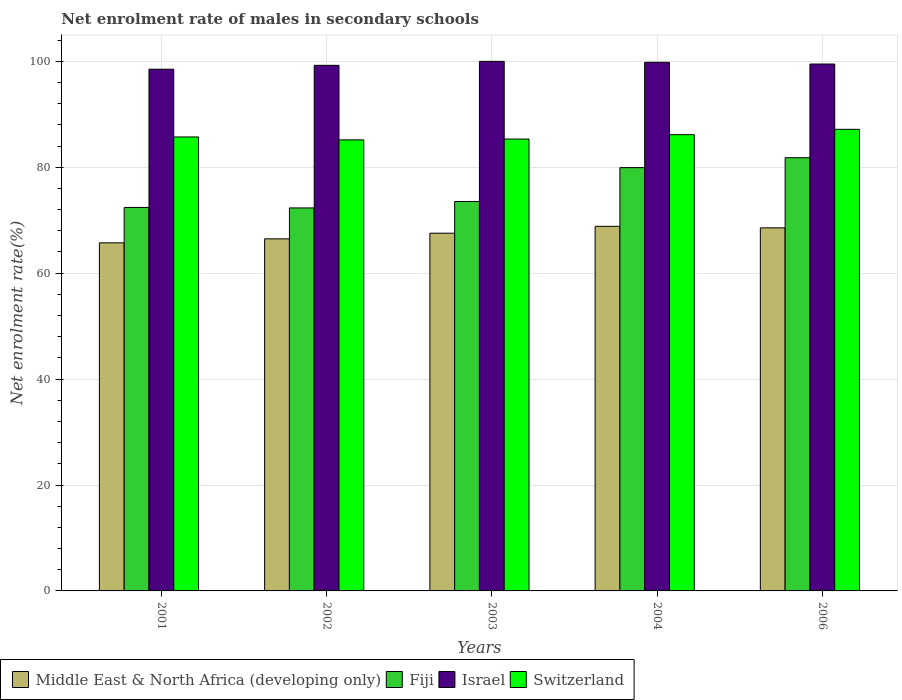How many groups of bars are there?
Make the answer very short. 5. Are the number of bars per tick equal to the number of legend labels?
Offer a very short reply. Yes. How many bars are there on the 2nd tick from the left?
Your response must be concise. 4. How many bars are there on the 5th tick from the right?
Your answer should be very brief. 4. What is the label of the 1st group of bars from the left?
Provide a succinct answer. 2001. What is the net enrolment rate of males in secondary schools in Middle East & North Africa (developing only) in 2001?
Offer a very short reply. 65.73. Across all years, what is the maximum net enrolment rate of males in secondary schools in Switzerland?
Provide a succinct answer. 87.17. Across all years, what is the minimum net enrolment rate of males in secondary schools in Fiji?
Your response must be concise. 72.32. In which year was the net enrolment rate of males in secondary schools in Middle East & North Africa (developing only) maximum?
Your answer should be very brief. 2004. In which year was the net enrolment rate of males in secondary schools in Israel minimum?
Provide a short and direct response. 2001. What is the total net enrolment rate of males in secondary schools in Middle East & North Africa (developing only) in the graph?
Ensure brevity in your answer.  337.18. What is the difference between the net enrolment rate of males in secondary schools in Israel in 2001 and that in 2004?
Your answer should be compact. -1.31. What is the difference between the net enrolment rate of males in secondary schools in Fiji in 2003 and the net enrolment rate of males in secondary schools in Switzerland in 2001?
Your answer should be very brief. -12.19. What is the average net enrolment rate of males in secondary schools in Fiji per year?
Provide a succinct answer. 76. In the year 2002, what is the difference between the net enrolment rate of males in secondary schools in Switzerland and net enrolment rate of males in secondary schools in Middle East & North Africa (developing only)?
Your response must be concise. 18.69. What is the ratio of the net enrolment rate of males in secondary schools in Fiji in 2001 to that in 2004?
Provide a short and direct response. 0.91. What is the difference between the highest and the second highest net enrolment rate of males in secondary schools in Switzerland?
Provide a succinct answer. 1.01. What is the difference between the highest and the lowest net enrolment rate of males in secondary schools in Middle East & North Africa (developing only)?
Your answer should be compact. 3.12. What does the 3rd bar from the left in 2001 represents?
Your answer should be compact. Israel. What does the 1st bar from the right in 2001 represents?
Provide a succinct answer. Switzerland. How many bars are there?
Your answer should be very brief. 20. Does the graph contain grids?
Give a very brief answer. Yes. Where does the legend appear in the graph?
Your answer should be very brief. Bottom left. How many legend labels are there?
Your answer should be compact. 4. What is the title of the graph?
Keep it short and to the point. Net enrolment rate of males in secondary schools. What is the label or title of the X-axis?
Your answer should be very brief. Years. What is the label or title of the Y-axis?
Your response must be concise. Net enrolment rate(%). What is the Net enrolment rate(%) in Middle East & North Africa (developing only) in 2001?
Make the answer very short. 65.73. What is the Net enrolment rate(%) of Fiji in 2001?
Provide a succinct answer. 72.42. What is the Net enrolment rate(%) of Israel in 2001?
Offer a very short reply. 98.52. What is the Net enrolment rate(%) of Switzerland in 2001?
Your answer should be compact. 85.72. What is the Net enrolment rate(%) of Middle East & North Africa (developing only) in 2002?
Provide a succinct answer. 66.48. What is the Net enrolment rate(%) in Fiji in 2002?
Your answer should be very brief. 72.32. What is the Net enrolment rate(%) of Israel in 2002?
Provide a succinct answer. 99.25. What is the Net enrolment rate(%) of Switzerland in 2002?
Your answer should be very brief. 85.17. What is the Net enrolment rate(%) in Middle East & North Africa (developing only) in 2003?
Offer a terse response. 67.55. What is the Net enrolment rate(%) in Fiji in 2003?
Provide a succinct answer. 73.54. What is the Net enrolment rate(%) in Switzerland in 2003?
Provide a succinct answer. 85.33. What is the Net enrolment rate(%) of Middle East & North Africa (developing only) in 2004?
Ensure brevity in your answer.  68.85. What is the Net enrolment rate(%) in Fiji in 2004?
Give a very brief answer. 79.93. What is the Net enrolment rate(%) in Israel in 2004?
Make the answer very short. 99.82. What is the Net enrolment rate(%) of Switzerland in 2004?
Offer a very short reply. 86.16. What is the Net enrolment rate(%) in Middle East & North Africa (developing only) in 2006?
Make the answer very short. 68.56. What is the Net enrolment rate(%) of Fiji in 2006?
Provide a succinct answer. 81.81. What is the Net enrolment rate(%) in Israel in 2006?
Provide a short and direct response. 99.5. What is the Net enrolment rate(%) of Switzerland in 2006?
Your answer should be very brief. 87.17. Across all years, what is the maximum Net enrolment rate(%) in Middle East & North Africa (developing only)?
Your answer should be compact. 68.85. Across all years, what is the maximum Net enrolment rate(%) in Fiji?
Ensure brevity in your answer.  81.81. Across all years, what is the maximum Net enrolment rate(%) in Switzerland?
Provide a succinct answer. 87.17. Across all years, what is the minimum Net enrolment rate(%) in Middle East & North Africa (developing only)?
Give a very brief answer. 65.73. Across all years, what is the minimum Net enrolment rate(%) of Fiji?
Your answer should be very brief. 72.32. Across all years, what is the minimum Net enrolment rate(%) of Israel?
Provide a succinct answer. 98.52. Across all years, what is the minimum Net enrolment rate(%) of Switzerland?
Your answer should be compact. 85.17. What is the total Net enrolment rate(%) in Middle East & North Africa (developing only) in the graph?
Provide a succinct answer. 337.18. What is the total Net enrolment rate(%) in Fiji in the graph?
Your answer should be very brief. 380.01. What is the total Net enrolment rate(%) of Israel in the graph?
Your answer should be compact. 497.08. What is the total Net enrolment rate(%) of Switzerland in the graph?
Your answer should be compact. 429.55. What is the difference between the Net enrolment rate(%) in Middle East & North Africa (developing only) in 2001 and that in 2002?
Your answer should be very brief. -0.75. What is the difference between the Net enrolment rate(%) in Fiji in 2001 and that in 2002?
Your answer should be very brief. 0.09. What is the difference between the Net enrolment rate(%) in Israel in 2001 and that in 2002?
Make the answer very short. -0.73. What is the difference between the Net enrolment rate(%) in Switzerland in 2001 and that in 2002?
Your answer should be compact. 0.55. What is the difference between the Net enrolment rate(%) in Middle East & North Africa (developing only) in 2001 and that in 2003?
Provide a short and direct response. -1.82. What is the difference between the Net enrolment rate(%) of Fiji in 2001 and that in 2003?
Keep it short and to the point. -1.12. What is the difference between the Net enrolment rate(%) of Israel in 2001 and that in 2003?
Ensure brevity in your answer.  -1.48. What is the difference between the Net enrolment rate(%) of Switzerland in 2001 and that in 2003?
Provide a short and direct response. 0.4. What is the difference between the Net enrolment rate(%) of Middle East & North Africa (developing only) in 2001 and that in 2004?
Offer a terse response. -3.12. What is the difference between the Net enrolment rate(%) in Fiji in 2001 and that in 2004?
Ensure brevity in your answer.  -7.52. What is the difference between the Net enrolment rate(%) in Israel in 2001 and that in 2004?
Your answer should be very brief. -1.31. What is the difference between the Net enrolment rate(%) of Switzerland in 2001 and that in 2004?
Ensure brevity in your answer.  -0.43. What is the difference between the Net enrolment rate(%) in Middle East & North Africa (developing only) in 2001 and that in 2006?
Your response must be concise. -2.83. What is the difference between the Net enrolment rate(%) of Fiji in 2001 and that in 2006?
Your response must be concise. -9.39. What is the difference between the Net enrolment rate(%) of Israel in 2001 and that in 2006?
Your response must be concise. -0.98. What is the difference between the Net enrolment rate(%) of Switzerland in 2001 and that in 2006?
Your answer should be compact. -1.44. What is the difference between the Net enrolment rate(%) of Middle East & North Africa (developing only) in 2002 and that in 2003?
Keep it short and to the point. -1.07. What is the difference between the Net enrolment rate(%) in Fiji in 2002 and that in 2003?
Give a very brief answer. -1.21. What is the difference between the Net enrolment rate(%) in Israel in 2002 and that in 2003?
Your answer should be very brief. -0.75. What is the difference between the Net enrolment rate(%) in Switzerland in 2002 and that in 2003?
Give a very brief answer. -0.16. What is the difference between the Net enrolment rate(%) in Middle East & North Africa (developing only) in 2002 and that in 2004?
Your answer should be compact. -2.36. What is the difference between the Net enrolment rate(%) in Fiji in 2002 and that in 2004?
Provide a succinct answer. -7.61. What is the difference between the Net enrolment rate(%) of Israel in 2002 and that in 2004?
Make the answer very short. -0.58. What is the difference between the Net enrolment rate(%) in Switzerland in 2002 and that in 2004?
Your answer should be compact. -0.98. What is the difference between the Net enrolment rate(%) in Middle East & North Africa (developing only) in 2002 and that in 2006?
Your response must be concise. -2.08. What is the difference between the Net enrolment rate(%) of Fiji in 2002 and that in 2006?
Your answer should be compact. -9.49. What is the difference between the Net enrolment rate(%) of Israel in 2002 and that in 2006?
Offer a very short reply. -0.25. What is the difference between the Net enrolment rate(%) of Switzerland in 2002 and that in 2006?
Offer a very short reply. -1.99. What is the difference between the Net enrolment rate(%) of Middle East & North Africa (developing only) in 2003 and that in 2004?
Offer a very short reply. -1.3. What is the difference between the Net enrolment rate(%) of Fiji in 2003 and that in 2004?
Ensure brevity in your answer.  -6.4. What is the difference between the Net enrolment rate(%) of Israel in 2003 and that in 2004?
Your answer should be very brief. 0.18. What is the difference between the Net enrolment rate(%) of Switzerland in 2003 and that in 2004?
Give a very brief answer. -0.83. What is the difference between the Net enrolment rate(%) of Middle East & North Africa (developing only) in 2003 and that in 2006?
Your answer should be compact. -1.01. What is the difference between the Net enrolment rate(%) of Fiji in 2003 and that in 2006?
Your response must be concise. -8.27. What is the difference between the Net enrolment rate(%) in Israel in 2003 and that in 2006?
Your response must be concise. 0.5. What is the difference between the Net enrolment rate(%) of Switzerland in 2003 and that in 2006?
Your answer should be compact. -1.84. What is the difference between the Net enrolment rate(%) of Middle East & North Africa (developing only) in 2004 and that in 2006?
Keep it short and to the point. 0.29. What is the difference between the Net enrolment rate(%) in Fiji in 2004 and that in 2006?
Provide a short and direct response. -1.87. What is the difference between the Net enrolment rate(%) in Israel in 2004 and that in 2006?
Give a very brief answer. 0.33. What is the difference between the Net enrolment rate(%) of Switzerland in 2004 and that in 2006?
Give a very brief answer. -1.01. What is the difference between the Net enrolment rate(%) of Middle East & North Africa (developing only) in 2001 and the Net enrolment rate(%) of Fiji in 2002?
Your answer should be very brief. -6.59. What is the difference between the Net enrolment rate(%) of Middle East & North Africa (developing only) in 2001 and the Net enrolment rate(%) of Israel in 2002?
Ensure brevity in your answer.  -33.51. What is the difference between the Net enrolment rate(%) in Middle East & North Africa (developing only) in 2001 and the Net enrolment rate(%) in Switzerland in 2002?
Provide a short and direct response. -19.44. What is the difference between the Net enrolment rate(%) of Fiji in 2001 and the Net enrolment rate(%) of Israel in 2002?
Give a very brief answer. -26.83. What is the difference between the Net enrolment rate(%) in Fiji in 2001 and the Net enrolment rate(%) in Switzerland in 2002?
Provide a succinct answer. -12.76. What is the difference between the Net enrolment rate(%) of Israel in 2001 and the Net enrolment rate(%) of Switzerland in 2002?
Ensure brevity in your answer.  13.34. What is the difference between the Net enrolment rate(%) of Middle East & North Africa (developing only) in 2001 and the Net enrolment rate(%) of Fiji in 2003?
Provide a succinct answer. -7.8. What is the difference between the Net enrolment rate(%) in Middle East & North Africa (developing only) in 2001 and the Net enrolment rate(%) in Israel in 2003?
Your answer should be compact. -34.27. What is the difference between the Net enrolment rate(%) in Middle East & North Africa (developing only) in 2001 and the Net enrolment rate(%) in Switzerland in 2003?
Provide a succinct answer. -19.6. What is the difference between the Net enrolment rate(%) of Fiji in 2001 and the Net enrolment rate(%) of Israel in 2003?
Give a very brief answer. -27.58. What is the difference between the Net enrolment rate(%) in Fiji in 2001 and the Net enrolment rate(%) in Switzerland in 2003?
Your answer should be very brief. -12.91. What is the difference between the Net enrolment rate(%) in Israel in 2001 and the Net enrolment rate(%) in Switzerland in 2003?
Offer a very short reply. 13.19. What is the difference between the Net enrolment rate(%) in Middle East & North Africa (developing only) in 2001 and the Net enrolment rate(%) in Fiji in 2004?
Offer a terse response. -14.2. What is the difference between the Net enrolment rate(%) in Middle East & North Africa (developing only) in 2001 and the Net enrolment rate(%) in Israel in 2004?
Ensure brevity in your answer.  -34.09. What is the difference between the Net enrolment rate(%) in Middle East & North Africa (developing only) in 2001 and the Net enrolment rate(%) in Switzerland in 2004?
Keep it short and to the point. -20.42. What is the difference between the Net enrolment rate(%) in Fiji in 2001 and the Net enrolment rate(%) in Israel in 2004?
Give a very brief answer. -27.41. What is the difference between the Net enrolment rate(%) in Fiji in 2001 and the Net enrolment rate(%) in Switzerland in 2004?
Make the answer very short. -13.74. What is the difference between the Net enrolment rate(%) in Israel in 2001 and the Net enrolment rate(%) in Switzerland in 2004?
Provide a short and direct response. 12.36. What is the difference between the Net enrolment rate(%) in Middle East & North Africa (developing only) in 2001 and the Net enrolment rate(%) in Fiji in 2006?
Offer a very short reply. -16.07. What is the difference between the Net enrolment rate(%) in Middle East & North Africa (developing only) in 2001 and the Net enrolment rate(%) in Israel in 2006?
Your answer should be very brief. -33.76. What is the difference between the Net enrolment rate(%) of Middle East & North Africa (developing only) in 2001 and the Net enrolment rate(%) of Switzerland in 2006?
Keep it short and to the point. -21.43. What is the difference between the Net enrolment rate(%) of Fiji in 2001 and the Net enrolment rate(%) of Israel in 2006?
Ensure brevity in your answer.  -27.08. What is the difference between the Net enrolment rate(%) in Fiji in 2001 and the Net enrolment rate(%) in Switzerland in 2006?
Offer a very short reply. -14.75. What is the difference between the Net enrolment rate(%) in Israel in 2001 and the Net enrolment rate(%) in Switzerland in 2006?
Make the answer very short. 11.35. What is the difference between the Net enrolment rate(%) of Middle East & North Africa (developing only) in 2002 and the Net enrolment rate(%) of Fiji in 2003?
Make the answer very short. -7.05. What is the difference between the Net enrolment rate(%) of Middle East & North Africa (developing only) in 2002 and the Net enrolment rate(%) of Israel in 2003?
Your response must be concise. -33.52. What is the difference between the Net enrolment rate(%) of Middle East & North Africa (developing only) in 2002 and the Net enrolment rate(%) of Switzerland in 2003?
Your response must be concise. -18.84. What is the difference between the Net enrolment rate(%) of Fiji in 2002 and the Net enrolment rate(%) of Israel in 2003?
Your answer should be very brief. -27.68. What is the difference between the Net enrolment rate(%) in Fiji in 2002 and the Net enrolment rate(%) in Switzerland in 2003?
Provide a succinct answer. -13.01. What is the difference between the Net enrolment rate(%) in Israel in 2002 and the Net enrolment rate(%) in Switzerland in 2003?
Your answer should be compact. 13.92. What is the difference between the Net enrolment rate(%) of Middle East & North Africa (developing only) in 2002 and the Net enrolment rate(%) of Fiji in 2004?
Ensure brevity in your answer.  -13.45. What is the difference between the Net enrolment rate(%) of Middle East & North Africa (developing only) in 2002 and the Net enrolment rate(%) of Israel in 2004?
Your answer should be very brief. -33.34. What is the difference between the Net enrolment rate(%) in Middle East & North Africa (developing only) in 2002 and the Net enrolment rate(%) in Switzerland in 2004?
Your response must be concise. -19.67. What is the difference between the Net enrolment rate(%) in Fiji in 2002 and the Net enrolment rate(%) in Israel in 2004?
Your answer should be very brief. -27.5. What is the difference between the Net enrolment rate(%) of Fiji in 2002 and the Net enrolment rate(%) of Switzerland in 2004?
Make the answer very short. -13.84. What is the difference between the Net enrolment rate(%) in Israel in 2002 and the Net enrolment rate(%) in Switzerland in 2004?
Your answer should be compact. 13.09. What is the difference between the Net enrolment rate(%) in Middle East & North Africa (developing only) in 2002 and the Net enrolment rate(%) in Fiji in 2006?
Your answer should be very brief. -15.32. What is the difference between the Net enrolment rate(%) of Middle East & North Africa (developing only) in 2002 and the Net enrolment rate(%) of Israel in 2006?
Your answer should be very brief. -33.01. What is the difference between the Net enrolment rate(%) in Middle East & North Africa (developing only) in 2002 and the Net enrolment rate(%) in Switzerland in 2006?
Ensure brevity in your answer.  -20.68. What is the difference between the Net enrolment rate(%) of Fiji in 2002 and the Net enrolment rate(%) of Israel in 2006?
Give a very brief answer. -27.18. What is the difference between the Net enrolment rate(%) in Fiji in 2002 and the Net enrolment rate(%) in Switzerland in 2006?
Make the answer very short. -14.85. What is the difference between the Net enrolment rate(%) of Israel in 2002 and the Net enrolment rate(%) of Switzerland in 2006?
Offer a very short reply. 12.08. What is the difference between the Net enrolment rate(%) in Middle East & North Africa (developing only) in 2003 and the Net enrolment rate(%) in Fiji in 2004?
Offer a terse response. -12.38. What is the difference between the Net enrolment rate(%) of Middle East & North Africa (developing only) in 2003 and the Net enrolment rate(%) of Israel in 2004?
Give a very brief answer. -32.27. What is the difference between the Net enrolment rate(%) of Middle East & North Africa (developing only) in 2003 and the Net enrolment rate(%) of Switzerland in 2004?
Your response must be concise. -18.6. What is the difference between the Net enrolment rate(%) of Fiji in 2003 and the Net enrolment rate(%) of Israel in 2004?
Provide a succinct answer. -26.29. What is the difference between the Net enrolment rate(%) of Fiji in 2003 and the Net enrolment rate(%) of Switzerland in 2004?
Your answer should be compact. -12.62. What is the difference between the Net enrolment rate(%) of Israel in 2003 and the Net enrolment rate(%) of Switzerland in 2004?
Make the answer very short. 13.84. What is the difference between the Net enrolment rate(%) of Middle East & North Africa (developing only) in 2003 and the Net enrolment rate(%) of Fiji in 2006?
Offer a very short reply. -14.25. What is the difference between the Net enrolment rate(%) of Middle East & North Africa (developing only) in 2003 and the Net enrolment rate(%) of Israel in 2006?
Offer a terse response. -31.95. What is the difference between the Net enrolment rate(%) of Middle East & North Africa (developing only) in 2003 and the Net enrolment rate(%) of Switzerland in 2006?
Offer a terse response. -19.61. What is the difference between the Net enrolment rate(%) in Fiji in 2003 and the Net enrolment rate(%) in Israel in 2006?
Make the answer very short. -25.96. What is the difference between the Net enrolment rate(%) in Fiji in 2003 and the Net enrolment rate(%) in Switzerland in 2006?
Your answer should be compact. -13.63. What is the difference between the Net enrolment rate(%) in Israel in 2003 and the Net enrolment rate(%) in Switzerland in 2006?
Your answer should be very brief. 12.83. What is the difference between the Net enrolment rate(%) in Middle East & North Africa (developing only) in 2004 and the Net enrolment rate(%) in Fiji in 2006?
Your response must be concise. -12.96. What is the difference between the Net enrolment rate(%) of Middle East & North Africa (developing only) in 2004 and the Net enrolment rate(%) of Israel in 2006?
Your answer should be very brief. -30.65. What is the difference between the Net enrolment rate(%) in Middle East & North Africa (developing only) in 2004 and the Net enrolment rate(%) in Switzerland in 2006?
Your response must be concise. -18.32. What is the difference between the Net enrolment rate(%) in Fiji in 2004 and the Net enrolment rate(%) in Israel in 2006?
Your answer should be compact. -19.56. What is the difference between the Net enrolment rate(%) in Fiji in 2004 and the Net enrolment rate(%) in Switzerland in 2006?
Your response must be concise. -7.23. What is the difference between the Net enrolment rate(%) of Israel in 2004 and the Net enrolment rate(%) of Switzerland in 2006?
Your response must be concise. 12.66. What is the average Net enrolment rate(%) of Middle East & North Africa (developing only) per year?
Offer a terse response. 67.44. What is the average Net enrolment rate(%) of Fiji per year?
Make the answer very short. 76. What is the average Net enrolment rate(%) of Israel per year?
Ensure brevity in your answer.  99.42. What is the average Net enrolment rate(%) in Switzerland per year?
Give a very brief answer. 85.91. In the year 2001, what is the difference between the Net enrolment rate(%) in Middle East & North Africa (developing only) and Net enrolment rate(%) in Fiji?
Your response must be concise. -6.68. In the year 2001, what is the difference between the Net enrolment rate(%) in Middle East & North Africa (developing only) and Net enrolment rate(%) in Israel?
Keep it short and to the point. -32.78. In the year 2001, what is the difference between the Net enrolment rate(%) in Middle East & North Africa (developing only) and Net enrolment rate(%) in Switzerland?
Offer a terse response. -19.99. In the year 2001, what is the difference between the Net enrolment rate(%) of Fiji and Net enrolment rate(%) of Israel?
Give a very brief answer. -26.1. In the year 2001, what is the difference between the Net enrolment rate(%) of Fiji and Net enrolment rate(%) of Switzerland?
Make the answer very short. -13.31. In the year 2001, what is the difference between the Net enrolment rate(%) of Israel and Net enrolment rate(%) of Switzerland?
Make the answer very short. 12.79. In the year 2002, what is the difference between the Net enrolment rate(%) of Middle East & North Africa (developing only) and Net enrolment rate(%) of Fiji?
Your answer should be compact. -5.84. In the year 2002, what is the difference between the Net enrolment rate(%) in Middle East & North Africa (developing only) and Net enrolment rate(%) in Israel?
Give a very brief answer. -32.76. In the year 2002, what is the difference between the Net enrolment rate(%) in Middle East & North Africa (developing only) and Net enrolment rate(%) in Switzerland?
Provide a succinct answer. -18.69. In the year 2002, what is the difference between the Net enrolment rate(%) in Fiji and Net enrolment rate(%) in Israel?
Offer a very short reply. -26.93. In the year 2002, what is the difference between the Net enrolment rate(%) in Fiji and Net enrolment rate(%) in Switzerland?
Offer a very short reply. -12.85. In the year 2002, what is the difference between the Net enrolment rate(%) of Israel and Net enrolment rate(%) of Switzerland?
Offer a very short reply. 14.07. In the year 2003, what is the difference between the Net enrolment rate(%) in Middle East & North Africa (developing only) and Net enrolment rate(%) in Fiji?
Your answer should be compact. -5.98. In the year 2003, what is the difference between the Net enrolment rate(%) in Middle East & North Africa (developing only) and Net enrolment rate(%) in Israel?
Your answer should be compact. -32.45. In the year 2003, what is the difference between the Net enrolment rate(%) in Middle East & North Africa (developing only) and Net enrolment rate(%) in Switzerland?
Your answer should be compact. -17.78. In the year 2003, what is the difference between the Net enrolment rate(%) of Fiji and Net enrolment rate(%) of Israel?
Give a very brief answer. -26.46. In the year 2003, what is the difference between the Net enrolment rate(%) of Fiji and Net enrolment rate(%) of Switzerland?
Make the answer very short. -11.79. In the year 2003, what is the difference between the Net enrolment rate(%) in Israel and Net enrolment rate(%) in Switzerland?
Offer a terse response. 14.67. In the year 2004, what is the difference between the Net enrolment rate(%) of Middle East & North Africa (developing only) and Net enrolment rate(%) of Fiji?
Offer a terse response. -11.08. In the year 2004, what is the difference between the Net enrolment rate(%) in Middle East & North Africa (developing only) and Net enrolment rate(%) in Israel?
Your answer should be compact. -30.97. In the year 2004, what is the difference between the Net enrolment rate(%) in Middle East & North Africa (developing only) and Net enrolment rate(%) in Switzerland?
Offer a very short reply. -17.31. In the year 2004, what is the difference between the Net enrolment rate(%) of Fiji and Net enrolment rate(%) of Israel?
Make the answer very short. -19.89. In the year 2004, what is the difference between the Net enrolment rate(%) in Fiji and Net enrolment rate(%) in Switzerland?
Give a very brief answer. -6.22. In the year 2004, what is the difference between the Net enrolment rate(%) in Israel and Net enrolment rate(%) in Switzerland?
Your response must be concise. 13.67. In the year 2006, what is the difference between the Net enrolment rate(%) of Middle East & North Africa (developing only) and Net enrolment rate(%) of Fiji?
Your response must be concise. -13.25. In the year 2006, what is the difference between the Net enrolment rate(%) in Middle East & North Africa (developing only) and Net enrolment rate(%) in Israel?
Keep it short and to the point. -30.94. In the year 2006, what is the difference between the Net enrolment rate(%) in Middle East & North Africa (developing only) and Net enrolment rate(%) in Switzerland?
Make the answer very short. -18.61. In the year 2006, what is the difference between the Net enrolment rate(%) of Fiji and Net enrolment rate(%) of Israel?
Your answer should be very brief. -17.69. In the year 2006, what is the difference between the Net enrolment rate(%) in Fiji and Net enrolment rate(%) in Switzerland?
Your response must be concise. -5.36. In the year 2006, what is the difference between the Net enrolment rate(%) in Israel and Net enrolment rate(%) in Switzerland?
Offer a very short reply. 12.33. What is the ratio of the Net enrolment rate(%) in Middle East & North Africa (developing only) in 2001 to that in 2002?
Keep it short and to the point. 0.99. What is the ratio of the Net enrolment rate(%) of Fiji in 2001 to that in 2002?
Make the answer very short. 1. What is the ratio of the Net enrolment rate(%) of Israel in 2001 to that in 2002?
Your answer should be very brief. 0.99. What is the ratio of the Net enrolment rate(%) in Middle East & North Africa (developing only) in 2001 to that in 2003?
Your answer should be very brief. 0.97. What is the ratio of the Net enrolment rate(%) of Israel in 2001 to that in 2003?
Ensure brevity in your answer.  0.99. What is the ratio of the Net enrolment rate(%) in Middle East & North Africa (developing only) in 2001 to that in 2004?
Your response must be concise. 0.95. What is the ratio of the Net enrolment rate(%) in Fiji in 2001 to that in 2004?
Provide a short and direct response. 0.91. What is the ratio of the Net enrolment rate(%) of Israel in 2001 to that in 2004?
Provide a short and direct response. 0.99. What is the ratio of the Net enrolment rate(%) of Middle East & North Africa (developing only) in 2001 to that in 2006?
Your answer should be very brief. 0.96. What is the ratio of the Net enrolment rate(%) in Fiji in 2001 to that in 2006?
Provide a succinct answer. 0.89. What is the ratio of the Net enrolment rate(%) of Israel in 2001 to that in 2006?
Offer a terse response. 0.99. What is the ratio of the Net enrolment rate(%) in Switzerland in 2001 to that in 2006?
Offer a terse response. 0.98. What is the ratio of the Net enrolment rate(%) in Middle East & North Africa (developing only) in 2002 to that in 2003?
Keep it short and to the point. 0.98. What is the ratio of the Net enrolment rate(%) of Fiji in 2002 to that in 2003?
Offer a terse response. 0.98. What is the ratio of the Net enrolment rate(%) in Middle East & North Africa (developing only) in 2002 to that in 2004?
Ensure brevity in your answer.  0.97. What is the ratio of the Net enrolment rate(%) of Fiji in 2002 to that in 2004?
Provide a succinct answer. 0.9. What is the ratio of the Net enrolment rate(%) of Israel in 2002 to that in 2004?
Keep it short and to the point. 0.99. What is the ratio of the Net enrolment rate(%) in Switzerland in 2002 to that in 2004?
Your response must be concise. 0.99. What is the ratio of the Net enrolment rate(%) of Middle East & North Africa (developing only) in 2002 to that in 2006?
Make the answer very short. 0.97. What is the ratio of the Net enrolment rate(%) in Fiji in 2002 to that in 2006?
Provide a succinct answer. 0.88. What is the ratio of the Net enrolment rate(%) in Switzerland in 2002 to that in 2006?
Offer a very short reply. 0.98. What is the ratio of the Net enrolment rate(%) in Middle East & North Africa (developing only) in 2003 to that in 2004?
Give a very brief answer. 0.98. What is the ratio of the Net enrolment rate(%) of Fiji in 2003 to that in 2004?
Offer a very short reply. 0.92. What is the ratio of the Net enrolment rate(%) of Switzerland in 2003 to that in 2004?
Your answer should be compact. 0.99. What is the ratio of the Net enrolment rate(%) of Fiji in 2003 to that in 2006?
Offer a terse response. 0.9. What is the ratio of the Net enrolment rate(%) of Switzerland in 2003 to that in 2006?
Keep it short and to the point. 0.98. What is the ratio of the Net enrolment rate(%) in Middle East & North Africa (developing only) in 2004 to that in 2006?
Provide a short and direct response. 1. What is the ratio of the Net enrolment rate(%) in Fiji in 2004 to that in 2006?
Provide a succinct answer. 0.98. What is the ratio of the Net enrolment rate(%) of Israel in 2004 to that in 2006?
Provide a succinct answer. 1. What is the ratio of the Net enrolment rate(%) of Switzerland in 2004 to that in 2006?
Your response must be concise. 0.99. What is the difference between the highest and the second highest Net enrolment rate(%) of Middle East & North Africa (developing only)?
Your answer should be compact. 0.29. What is the difference between the highest and the second highest Net enrolment rate(%) in Fiji?
Your response must be concise. 1.87. What is the difference between the highest and the second highest Net enrolment rate(%) in Israel?
Offer a very short reply. 0.18. What is the difference between the highest and the second highest Net enrolment rate(%) in Switzerland?
Give a very brief answer. 1.01. What is the difference between the highest and the lowest Net enrolment rate(%) of Middle East & North Africa (developing only)?
Give a very brief answer. 3.12. What is the difference between the highest and the lowest Net enrolment rate(%) in Fiji?
Your answer should be compact. 9.49. What is the difference between the highest and the lowest Net enrolment rate(%) of Israel?
Make the answer very short. 1.48. What is the difference between the highest and the lowest Net enrolment rate(%) of Switzerland?
Offer a terse response. 1.99. 